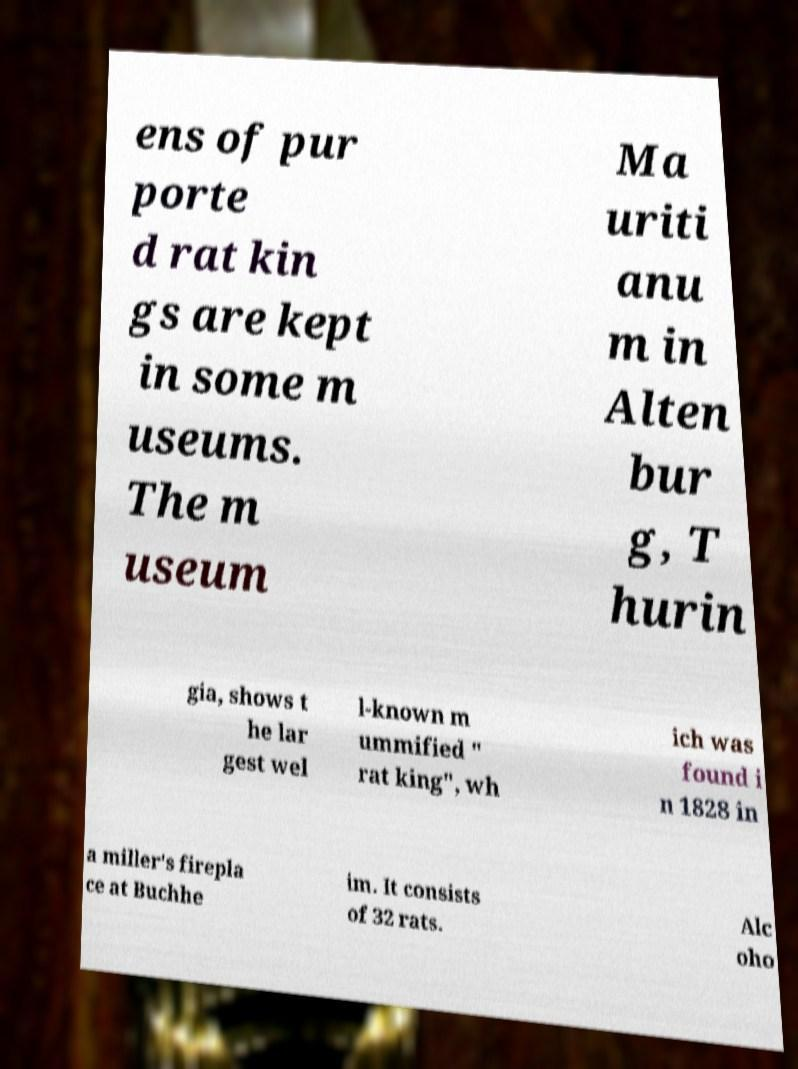Please identify and transcribe the text found in this image. ens of pur porte d rat kin gs are kept in some m useums. The m useum Ma uriti anu m in Alten bur g, T hurin gia, shows t he lar gest wel l-known m ummified " rat king", wh ich was found i n 1828 in a miller's firepla ce at Buchhe im. It consists of 32 rats. Alc oho 